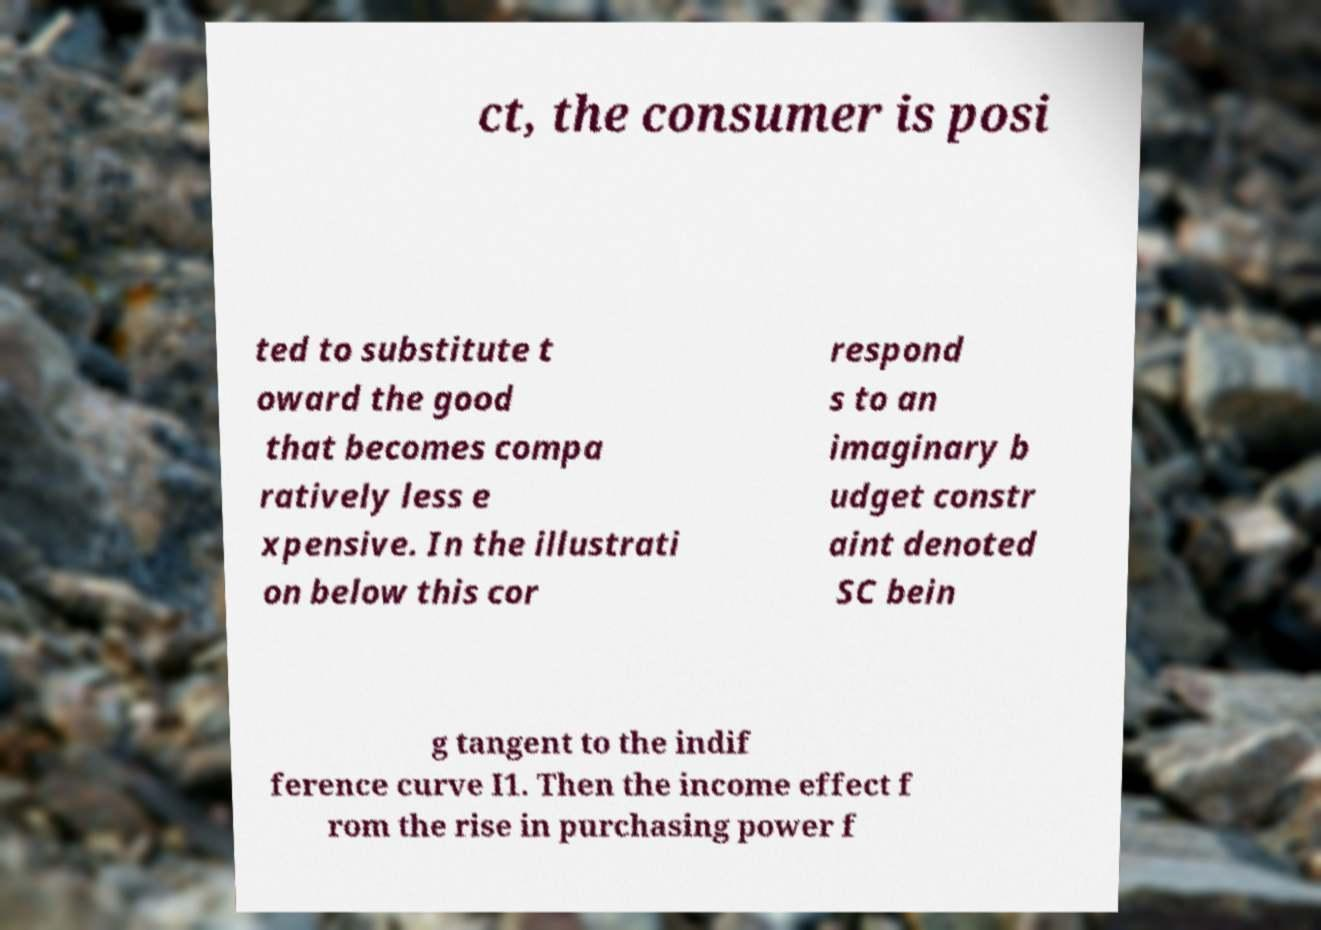Please identify and transcribe the text found in this image. ct, the consumer is posi ted to substitute t oward the good that becomes compa ratively less e xpensive. In the illustrati on below this cor respond s to an imaginary b udget constr aint denoted SC bein g tangent to the indif ference curve I1. Then the income effect f rom the rise in purchasing power f 